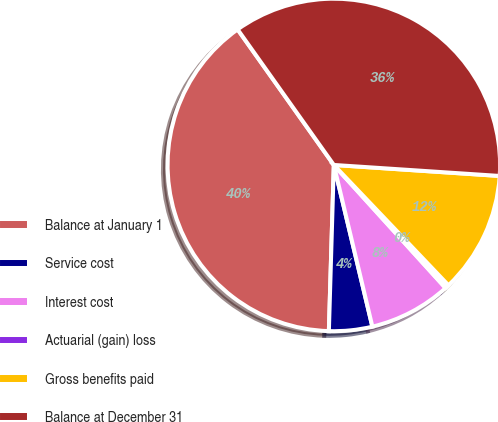<chart> <loc_0><loc_0><loc_500><loc_500><pie_chart><fcel>Balance at January 1<fcel>Service cost<fcel>Interest cost<fcel>Actuarial (gain) loss<fcel>Gross benefits paid<fcel>Balance at December 31<nl><fcel>39.7%<fcel>4.2%<fcel>8.01%<fcel>0.38%<fcel>11.83%<fcel>35.88%<nl></chart> 